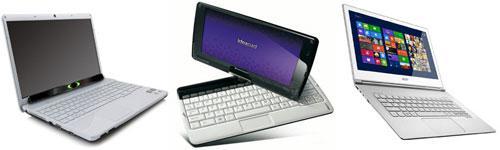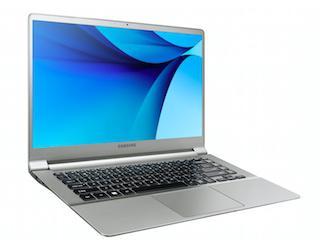The first image is the image on the left, the second image is the image on the right. Given the left and right images, does the statement "One photo contains multiple laptops." hold true? Answer yes or no. Yes. The first image is the image on the left, the second image is the image on the right. Given the left and right images, does the statement "Each image contains exactly one laptop-type device." hold true? Answer yes or no. No. 